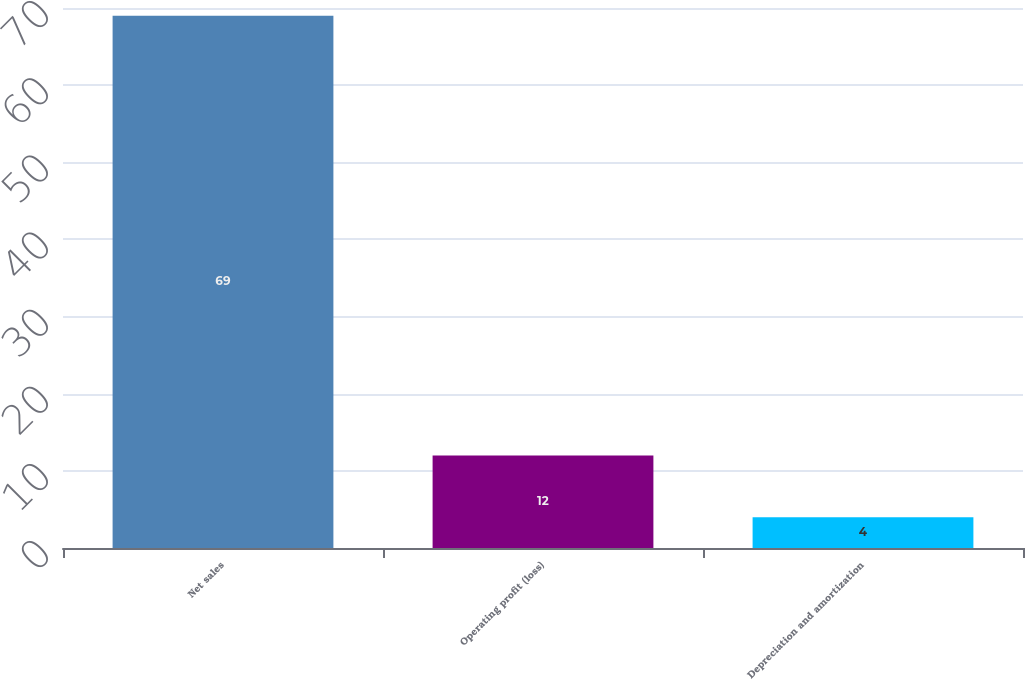Convert chart to OTSL. <chart><loc_0><loc_0><loc_500><loc_500><bar_chart><fcel>Net sales<fcel>Operating profit (loss)<fcel>Depreciation and amortization<nl><fcel>69<fcel>12<fcel>4<nl></chart> 